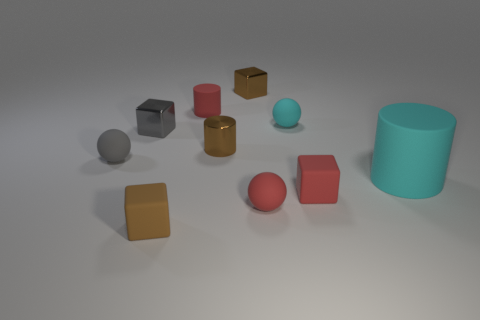What number of tiny rubber objects are the same color as the big thing?
Provide a short and direct response. 1. Does the rubber cube that is left of the red sphere have the same color as the tiny metallic cylinder?
Make the answer very short. Yes. Does the tiny brown cylinder have the same material as the gray block?
Make the answer very short. Yes. There is a small object that is left of the tiny brown metallic cylinder and on the right side of the tiny brown matte block; what material is it?
Make the answer very short. Rubber. The metal block that is to the right of the red rubber cylinder is what color?
Ensure brevity in your answer.  Brown. Is the number of matte cubes left of the brown cylinder greater than the number of big red cylinders?
Your response must be concise. Yes. How many other things are there of the same size as the gray ball?
Your answer should be very brief. 8. What number of small metallic blocks are in front of the tiny cyan matte object?
Offer a very short reply. 1. Are there an equal number of tiny red matte objects that are in front of the red matte cube and small cyan matte objects that are in front of the small cyan rubber object?
Offer a very short reply. No. There is a small red matte thing behind the large matte object; what is its shape?
Your answer should be compact. Cylinder. 